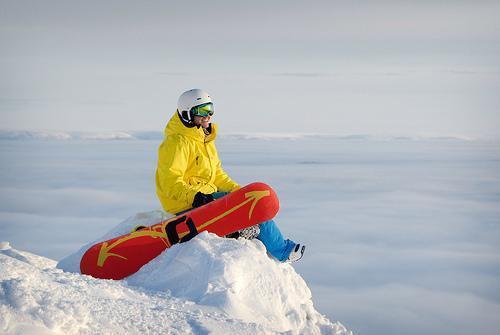How many people are in the picture?
Give a very brief answer. 1. 